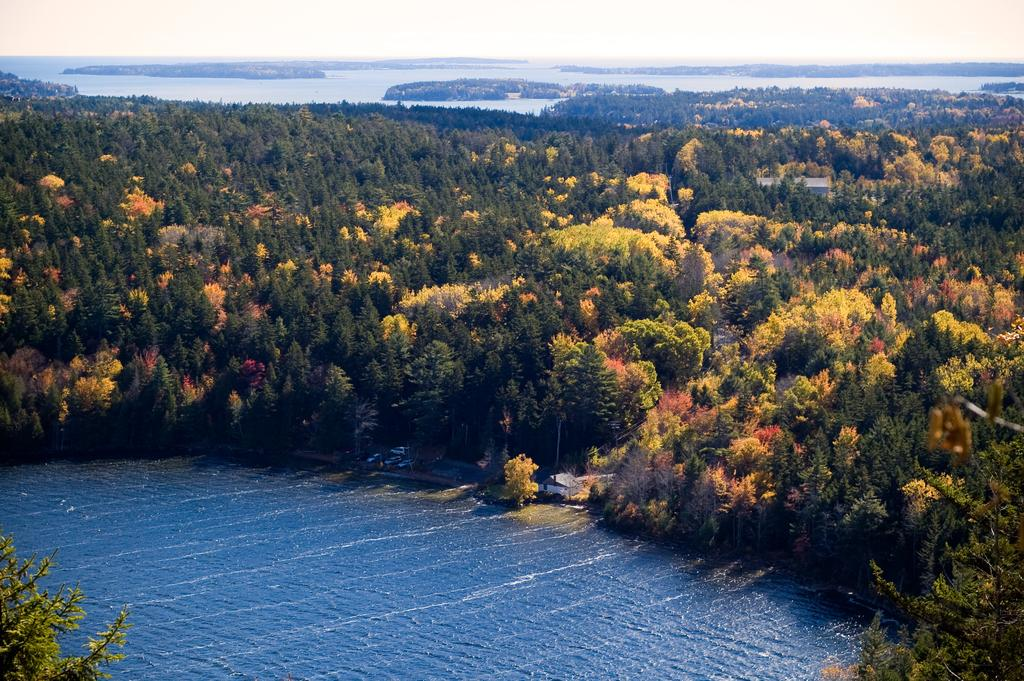What type of vegetation can be seen in the image? There are trees in the image. What type of structure is present in the image? There is a house in the image. What is visible at the bottom of the image? There is water visible at the bottom of the image. What is visible in the background of the image? There is sky and an ocean visible in the background of the image. Can you see a fireman putting out a fire in the image? There is no fireman or fire present in the image. What type of ball is being used in the image? There is no ball present in the image. 